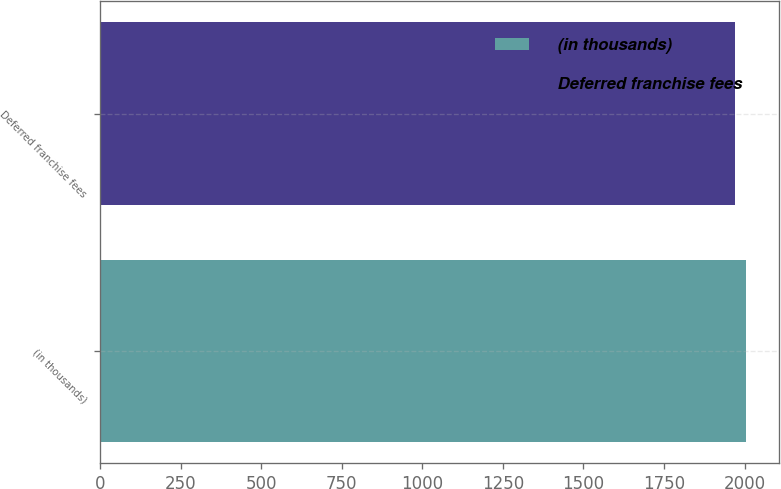<chart> <loc_0><loc_0><loc_500><loc_500><bar_chart><fcel>(in thousands)<fcel>Deferred franchise fees<nl><fcel>2005<fcel>1971<nl></chart> 